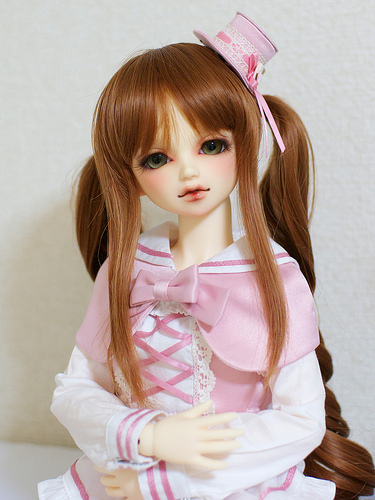<image>
Can you confirm if the toy is behind the wall? No. The toy is not behind the wall. From this viewpoint, the toy appears to be positioned elsewhere in the scene. Where is the doll in relation to the dress? Is it on the dress? No. The doll is not positioned on the dress. They may be near each other, but the doll is not supported by or resting on top of the dress. 